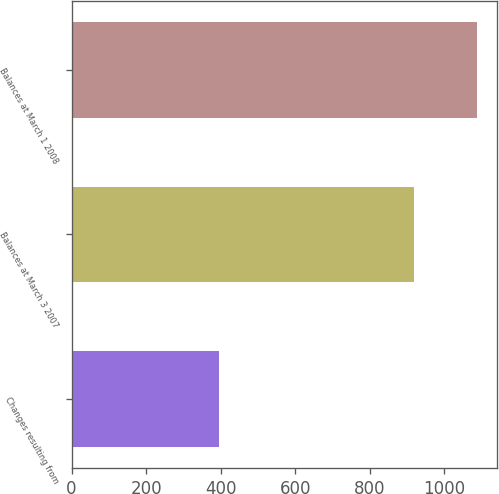Convert chart to OTSL. <chart><loc_0><loc_0><loc_500><loc_500><bar_chart><fcel>Changes resulting from<fcel>Balances at March 3 2007<fcel>Balances at March 1 2008<nl><fcel>396<fcel>919<fcel>1088<nl></chart> 